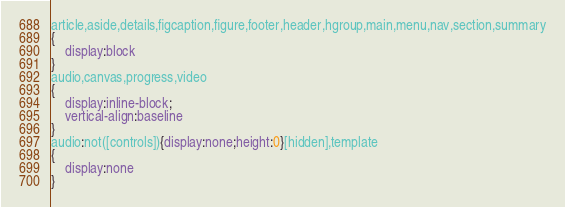<code> <loc_0><loc_0><loc_500><loc_500><_CSS_>article,aside,details,figcaption,figure,footer,header,hgroup,main,menu,nav,section,summary
{
    display:block
}
audio,canvas,progress,video
{
    display:inline-block;
    vertical-align:baseline
}
audio:not([controls]){display:none;height:0}[hidden],template
{
    display:none
}</code> 